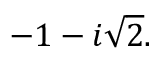Convert formula to latex. <formula><loc_0><loc_0><loc_500><loc_500>- 1 - i { \sqrt { 2 } } .</formula> 